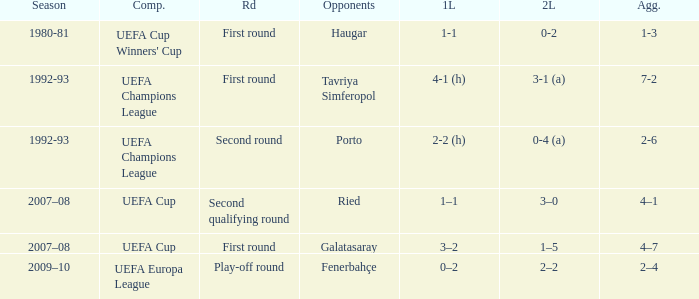 what's the aggregate where 1st leg is 3–2 4–7. 